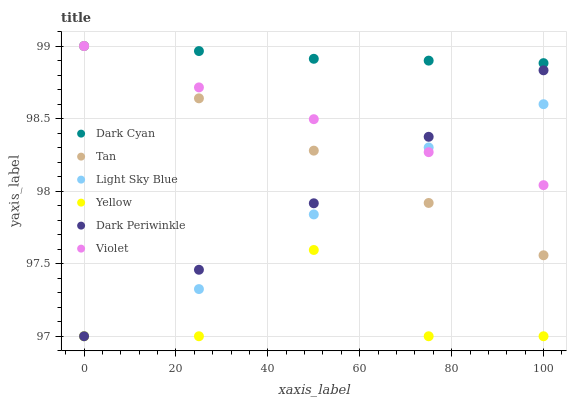Does Yellow have the minimum area under the curve?
Answer yes or no. Yes. Does Dark Cyan have the maximum area under the curve?
Answer yes or no. Yes. Does Light Sky Blue have the minimum area under the curve?
Answer yes or no. No. Does Light Sky Blue have the maximum area under the curve?
Answer yes or no. No. Is Tan the smoothest?
Answer yes or no. Yes. Is Yellow the roughest?
Answer yes or no. Yes. Is Light Sky Blue the smoothest?
Answer yes or no. No. Is Light Sky Blue the roughest?
Answer yes or no. No. Does Yellow have the lowest value?
Answer yes or no. Yes. Does Violet have the lowest value?
Answer yes or no. No. Does Tan have the highest value?
Answer yes or no. Yes. Does Light Sky Blue have the highest value?
Answer yes or no. No. Is Dark Periwinkle less than Dark Cyan?
Answer yes or no. Yes. Is Violet greater than Yellow?
Answer yes or no. Yes. Does Tan intersect Light Sky Blue?
Answer yes or no. Yes. Is Tan less than Light Sky Blue?
Answer yes or no. No. Is Tan greater than Light Sky Blue?
Answer yes or no. No. Does Dark Periwinkle intersect Dark Cyan?
Answer yes or no. No. 